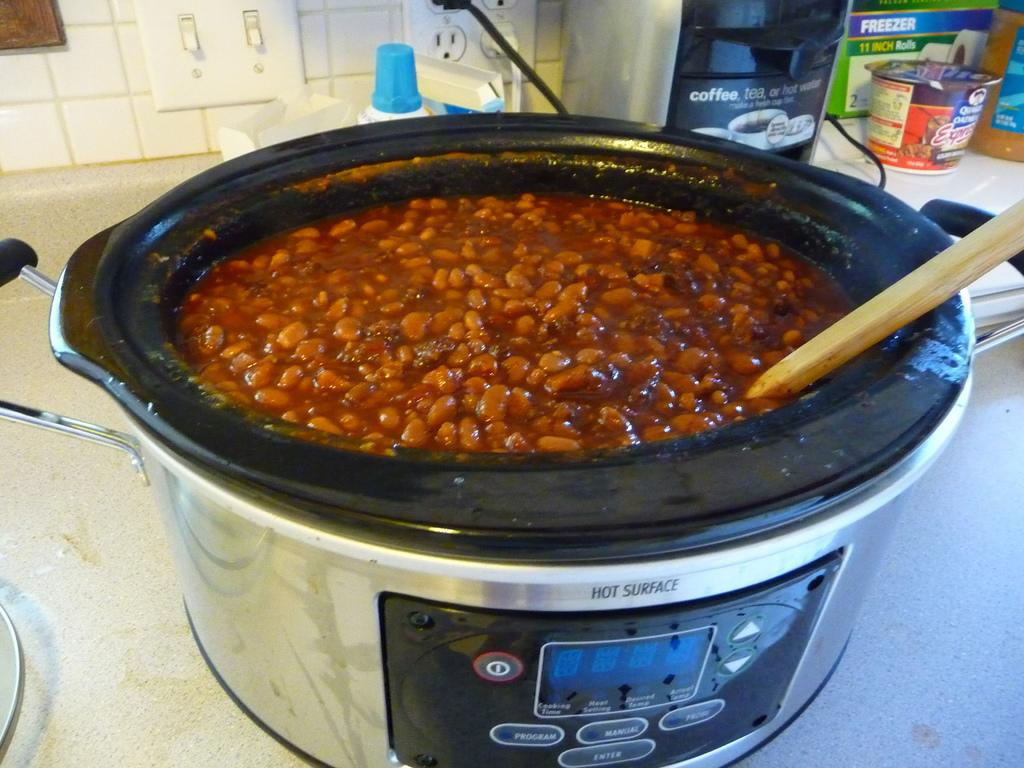<image>
Offer a succinct explanation of the picture presented. Some beans in a crockpot that has a surface labeled for being hot. 